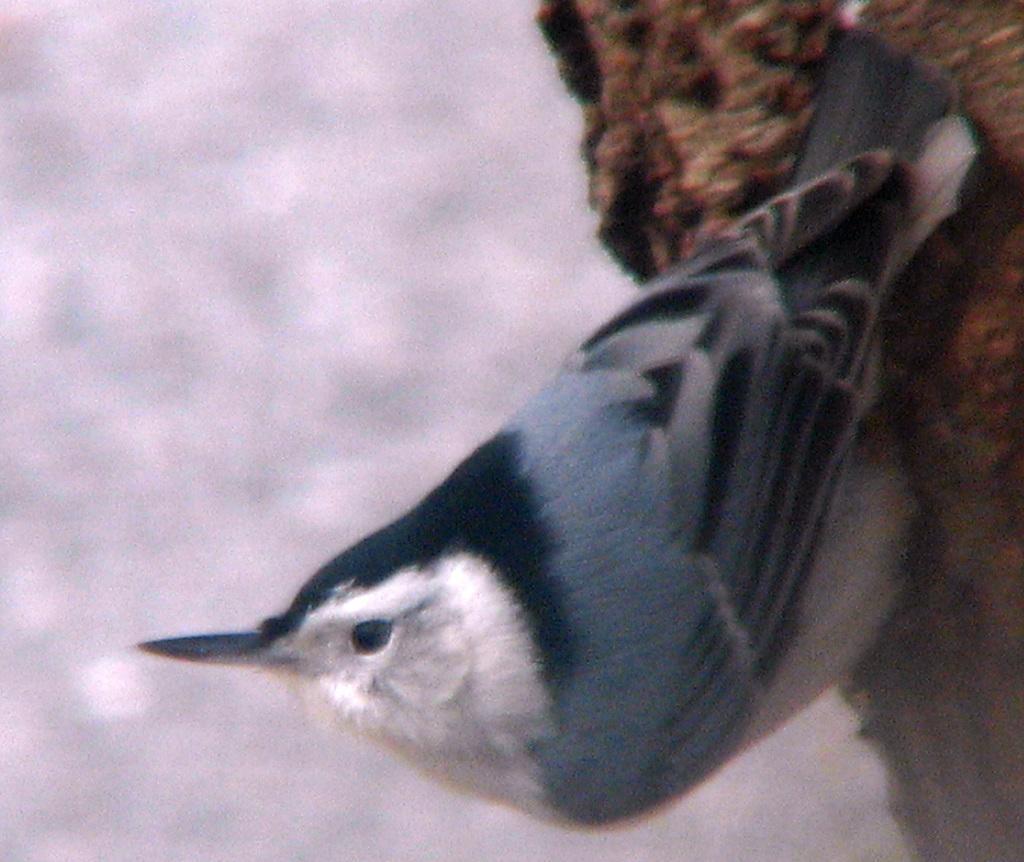Please provide a concise description of this image. In the center of the image, we can see a bird on the tree trunk. 